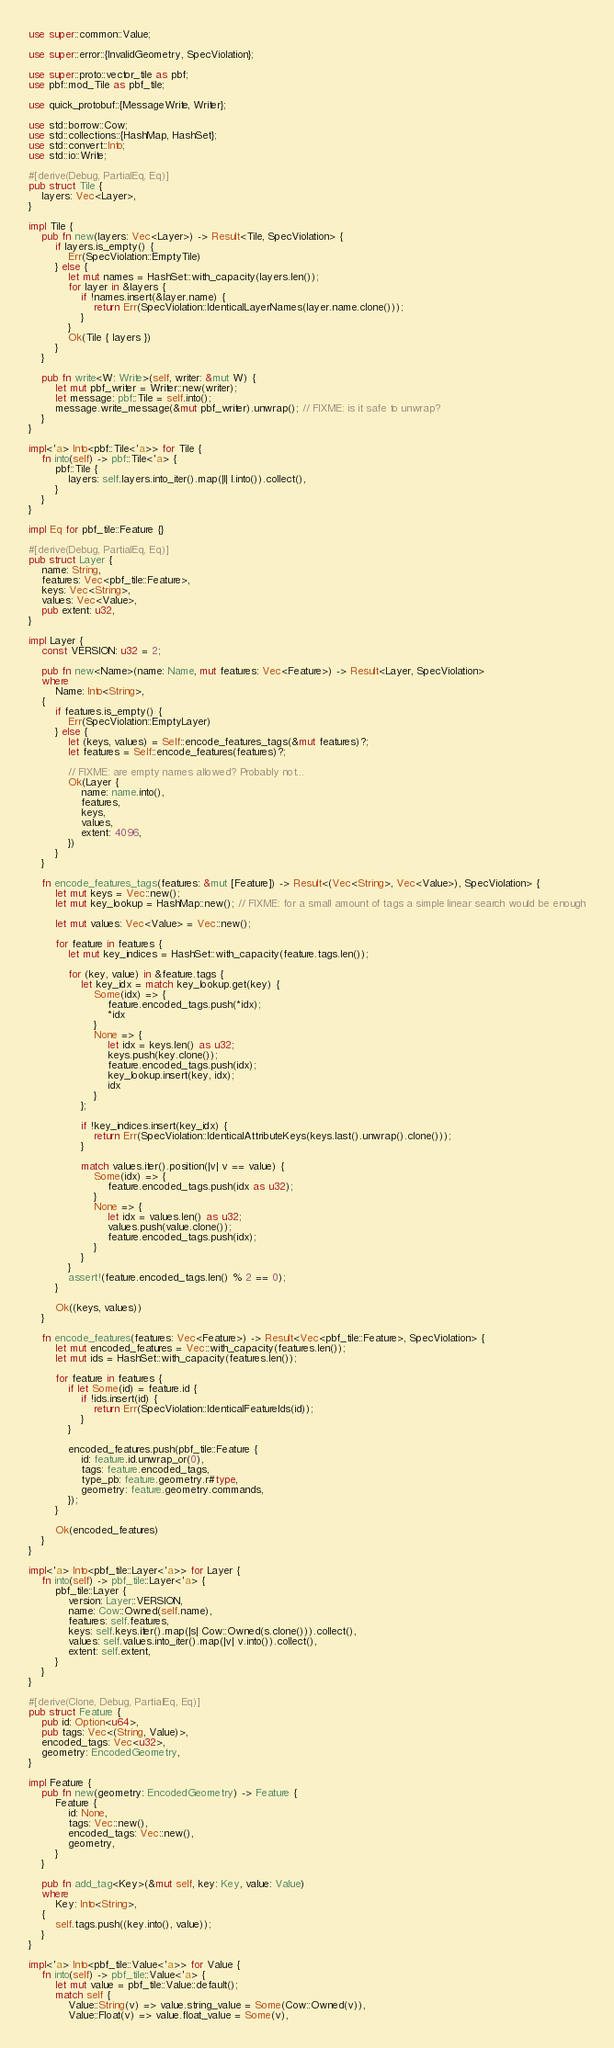Convert code to text. <code><loc_0><loc_0><loc_500><loc_500><_Rust_>use super::common::Value;

use super::error::{InvalidGeometry, SpecViolation};

use super::proto::vector_tile as pbf;
use pbf::mod_Tile as pbf_tile;

use quick_protobuf::{MessageWrite, Writer};

use std::borrow::Cow;
use std::collections::{HashMap, HashSet};
use std::convert::Into;
use std::io::Write;

#[derive(Debug, PartialEq, Eq)]
pub struct Tile {
    layers: Vec<Layer>,
}

impl Tile {
    pub fn new(layers: Vec<Layer>) -> Result<Tile, SpecViolation> {
        if layers.is_empty() {
            Err(SpecViolation::EmptyTile)
        } else {
            let mut names = HashSet::with_capacity(layers.len());
            for layer in &layers {
                if !names.insert(&layer.name) {
                    return Err(SpecViolation::IdenticalLayerNames(layer.name.clone()));
                }
            }
            Ok(Tile { layers })
        }
    }

    pub fn write<W: Write>(self, writer: &mut W) {
        let mut pbf_writer = Writer::new(writer);
        let message: pbf::Tile = self.into();
        message.write_message(&mut pbf_writer).unwrap(); // FIXME: is it safe to unwrap?
    }
}

impl<'a> Into<pbf::Tile<'a>> for Tile {
    fn into(self) -> pbf::Tile<'a> {
        pbf::Tile {
            layers: self.layers.into_iter().map(|l| l.into()).collect(),
        }
    }
}

impl Eq for pbf_tile::Feature {}

#[derive(Debug, PartialEq, Eq)]
pub struct Layer {
    name: String,
    features: Vec<pbf_tile::Feature>,
    keys: Vec<String>,
    values: Vec<Value>,
    pub extent: u32,
}

impl Layer {
    const VERSION: u32 = 2;

    pub fn new<Name>(name: Name, mut features: Vec<Feature>) -> Result<Layer, SpecViolation>
    where
        Name: Into<String>,
    {
        if features.is_empty() {
            Err(SpecViolation::EmptyLayer)
        } else {
            let (keys, values) = Self::encode_features_tags(&mut features)?;
            let features = Self::encode_features(features)?;

            // FIXME: are empty names allowed? Probably not...
            Ok(Layer {
                name: name.into(),
                features,
                keys,
                values,
                extent: 4096,
            })
        }
    }

    fn encode_features_tags(features: &mut [Feature]) -> Result<(Vec<String>, Vec<Value>), SpecViolation> {
        let mut keys = Vec::new();
        let mut key_lookup = HashMap::new(); // FIXME: for a small amount of tags a simple linear search would be enough

        let mut values: Vec<Value> = Vec::new();

        for feature in features {
            let mut key_indices = HashSet::with_capacity(feature.tags.len());

            for (key, value) in &feature.tags {
                let key_idx = match key_lookup.get(key) {
                    Some(idx) => {
                        feature.encoded_tags.push(*idx);
                        *idx
                    }
                    None => {
                        let idx = keys.len() as u32;
                        keys.push(key.clone());
                        feature.encoded_tags.push(idx);
                        key_lookup.insert(key, idx);
                        idx
                    }
                };

                if !key_indices.insert(key_idx) {
                    return Err(SpecViolation::IdenticalAttributeKeys(keys.last().unwrap().clone()));
                }

                match values.iter().position(|v| v == value) {
                    Some(idx) => {
                        feature.encoded_tags.push(idx as u32);
                    }
                    None => {
                        let idx = values.len() as u32;
                        values.push(value.clone());
                        feature.encoded_tags.push(idx);
                    }
                }
            }
            assert!(feature.encoded_tags.len() % 2 == 0);
        }

        Ok((keys, values))
    }

    fn encode_features(features: Vec<Feature>) -> Result<Vec<pbf_tile::Feature>, SpecViolation> {
        let mut encoded_features = Vec::with_capacity(features.len());
        let mut ids = HashSet::with_capacity(features.len());

        for feature in features {
            if let Some(id) = feature.id {
                if !ids.insert(id) {
                    return Err(SpecViolation::IdenticalFeatureIds(id));
                }
            }

            encoded_features.push(pbf_tile::Feature {
                id: feature.id.unwrap_or(0),
                tags: feature.encoded_tags,
                type_pb: feature.geometry.r#type,
                geometry: feature.geometry.commands,
            });
        }

        Ok(encoded_features)
    }
}

impl<'a> Into<pbf_tile::Layer<'a>> for Layer {
    fn into(self) -> pbf_tile::Layer<'a> {
        pbf_tile::Layer {
            version: Layer::VERSION,
            name: Cow::Owned(self.name),
            features: self.features,
            keys: self.keys.iter().map(|s| Cow::Owned(s.clone())).collect(),
            values: self.values.into_iter().map(|v| v.into()).collect(),
            extent: self.extent,
        }
    }
}

#[derive(Clone, Debug, PartialEq, Eq)]
pub struct Feature {
    pub id: Option<u64>,
    pub tags: Vec<(String, Value)>,
    encoded_tags: Vec<u32>,
    geometry: EncodedGeometry,
}

impl Feature {
    pub fn new(geometry: EncodedGeometry) -> Feature {
        Feature {
            id: None,
            tags: Vec::new(),
            encoded_tags: Vec::new(),
            geometry,
        }
    }

    pub fn add_tag<Key>(&mut self, key: Key, value: Value)
    where
        Key: Into<String>,
    {
        self.tags.push((key.into(), value));
    }
}

impl<'a> Into<pbf_tile::Value<'a>> for Value {
    fn into(self) -> pbf_tile::Value<'a> {
        let mut value = pbf_tile::Value::default();
        match self {
            Value::String(v) => value.string_value = Some(Cow::Owned(v)),
            Value::Float(v) => value.float_value = Some(v),</code> 